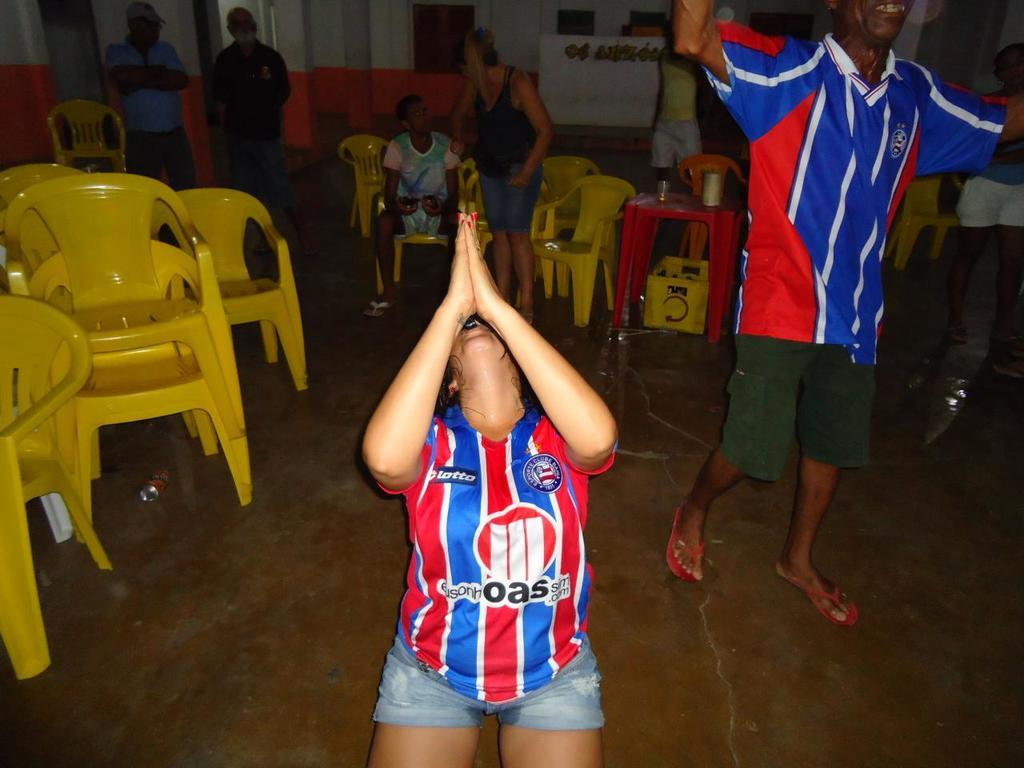Provide a one-sentence caption for the provided image. C Lotto is in the upper right hand side of the red and blue shirt. 